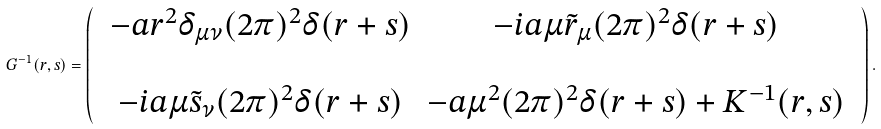<formula> <loc_0><loc_0><loc_500><loc_500>G ^ { - 1 } ( r , s ) = \begin{pmatrix} & - a r ^ { 2 } \delta _ { \mu \nu } ( 2 \pi ) ^ { 2 } \delta ( r + s ) & - i a \mu \tilde { r } _ { \mu } ( 2 \pi ) ^ { 2 } \delta ( r + s ) & \\ \\ & - i a \mu \tilde { s } _ { \nu } ( 2 \pi ) ^ { 2 } \delta ( r + s ) & - a \mu ^ { 2 } ( 2 \pi ) ^ { 2 } \delta ( r + s ) + K ^ { - 1 } ( r , s ) \end{pmatrix} .</formula> 